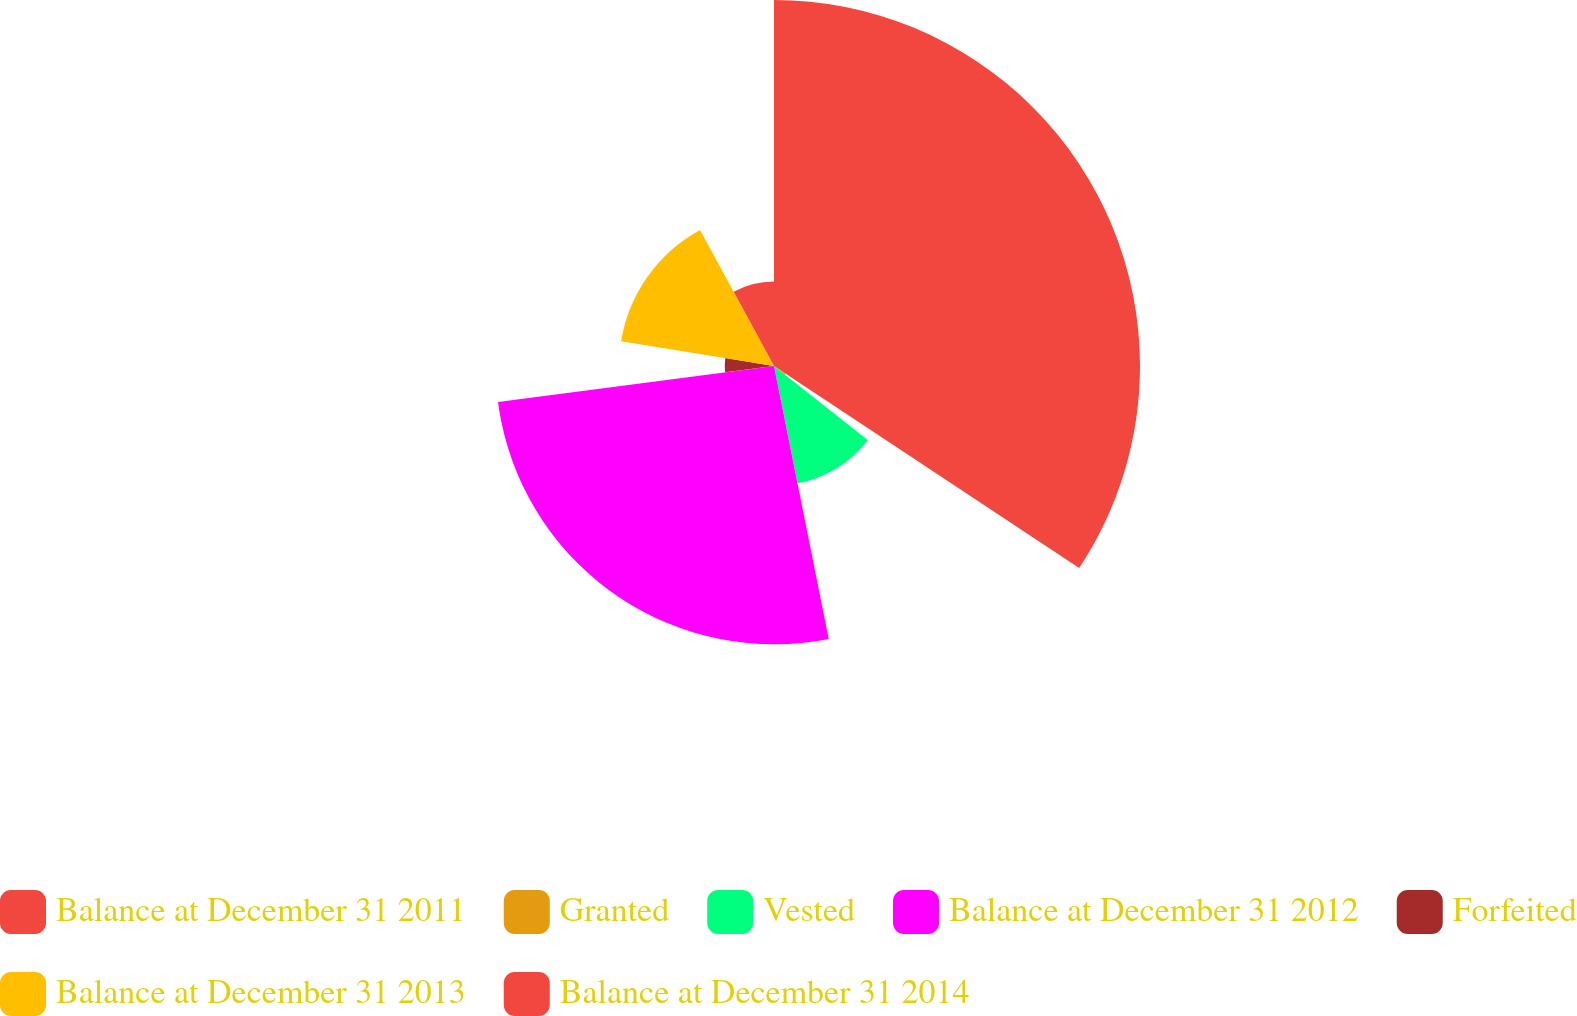Convert chart to OTSL. <chart><loc_0><loc_0><loc_500><loc_500><pie_chart><fcel>Balance at December 31 2011<fcel>Granted<fcel>Vested<fcel>Balance at December 31 2012<fcel>Forfeited<fcel>Balance at December 31 2013<fcel>Balance at December 31 2014<nl><fcel>34.31%<fcel>1.32%<fcel>11.22%<fcel>26.09%<fcel>4.62%<fcel>14.52%<fcel>7.92%<nl></chart> 